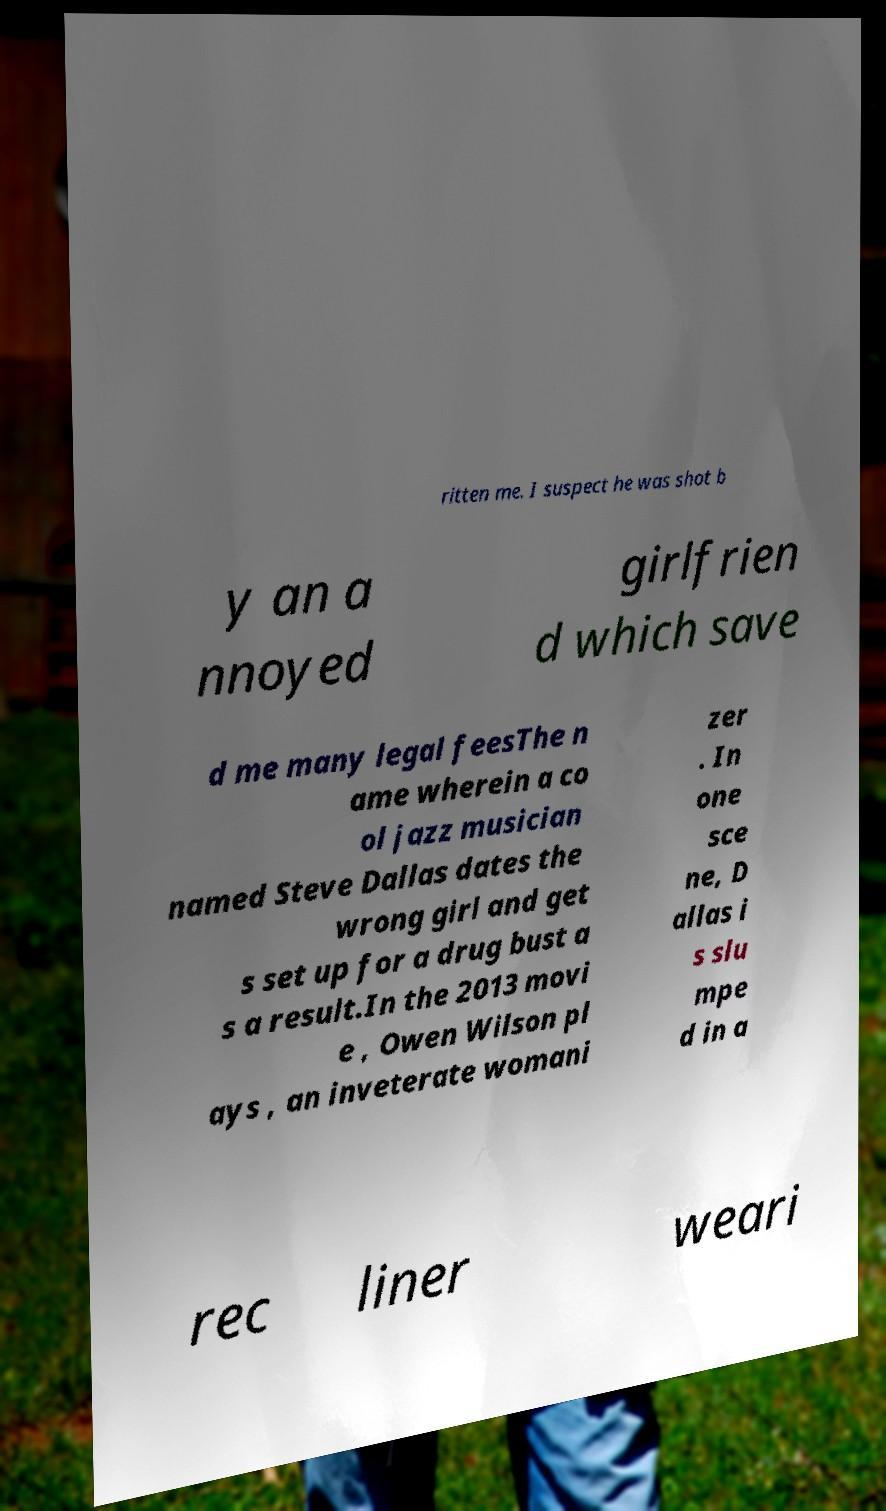Could you assist in decoding the text presented in this image and type it out clearly? ritten me. I suspect he was shot b y an a nnoyed girlfrien d which save d me many legal feesThe n ame wherein a co ol jazz musician named Steve Dallas dates the wrong girl and get s set up for a drug bust a s a result.In the 2013 movi e , Owen Wilson pl ays , an inveterate womani zer . In one sce ne, D allas i s slu mpe d in a rec liner weari 